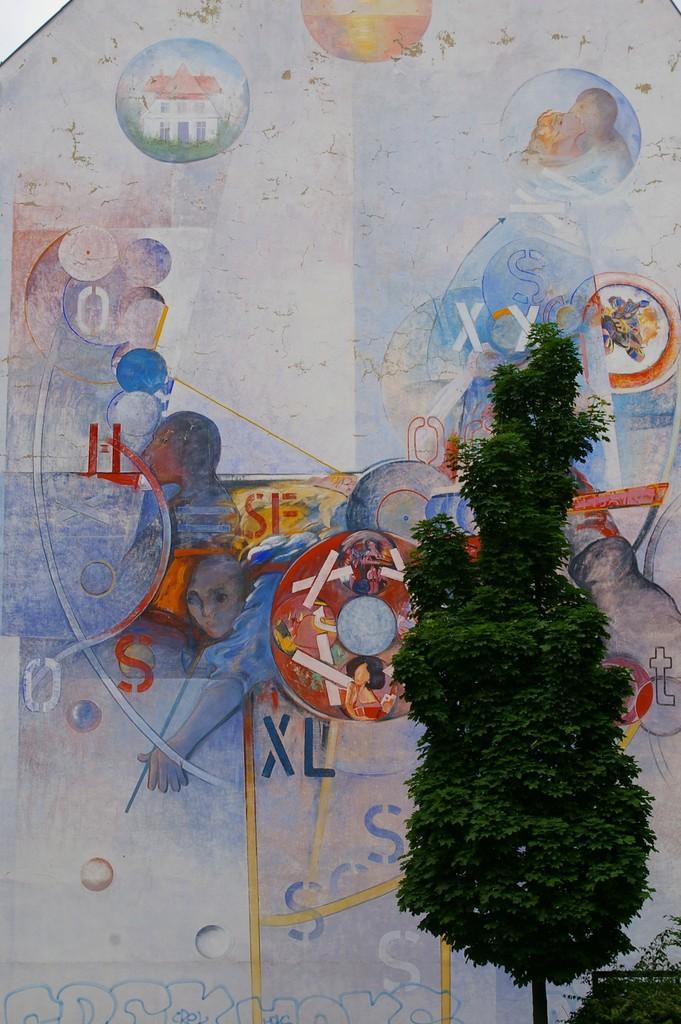In one or two sentences, can you explain what this image depicts? In this picture there is a tree on the right side of the image, it seems to be there is a painting on the wall in the background area of the image. 